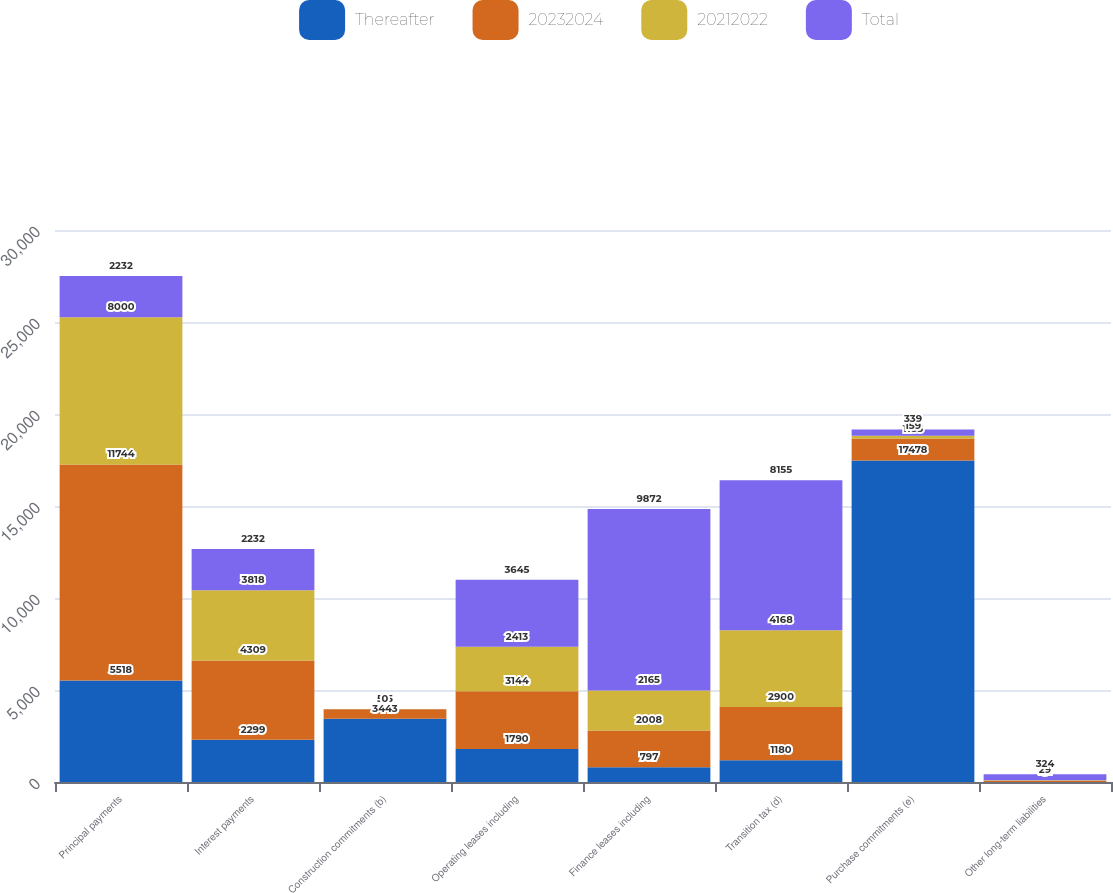Convert chart. <chart><loc_0><loc_0><loc_500><loc_500><stacked_bar_chart><ecel><fcel>Principal payments<fcel>Interest payments<fcel>Construction commitments (b)<fcel>Operating leases including<fcel>Finance leases including<fcel>Transition tax (d)<fcel>Purchase commitments (e)<fcel>Other long-term liabilities<nl><fcel>Thereafter<fcel>5518<fcel>2299<fcel>3443<fcel>1790<fcel>797<fcel>1180<fcel>17478<fcel>0<nl><fcel>20232024<fcel>11744<fcel>4309<fcel>515<fcel>3144<fcel>2008<fcel>2900<fcel>1185<fcel>72<nl><fcel>20212022<fcel>8000<fcel>3818<fcel>0<fcel>2413<fcel>2165<fcel>4168<fcel>159<fcel>29<nl><fcel>Total<fcel>2232<fcel>2232<fcel>0<fcel>3645<fcel>9872<fcel>8155<fcel>339<fcel>324<nl></chart> 